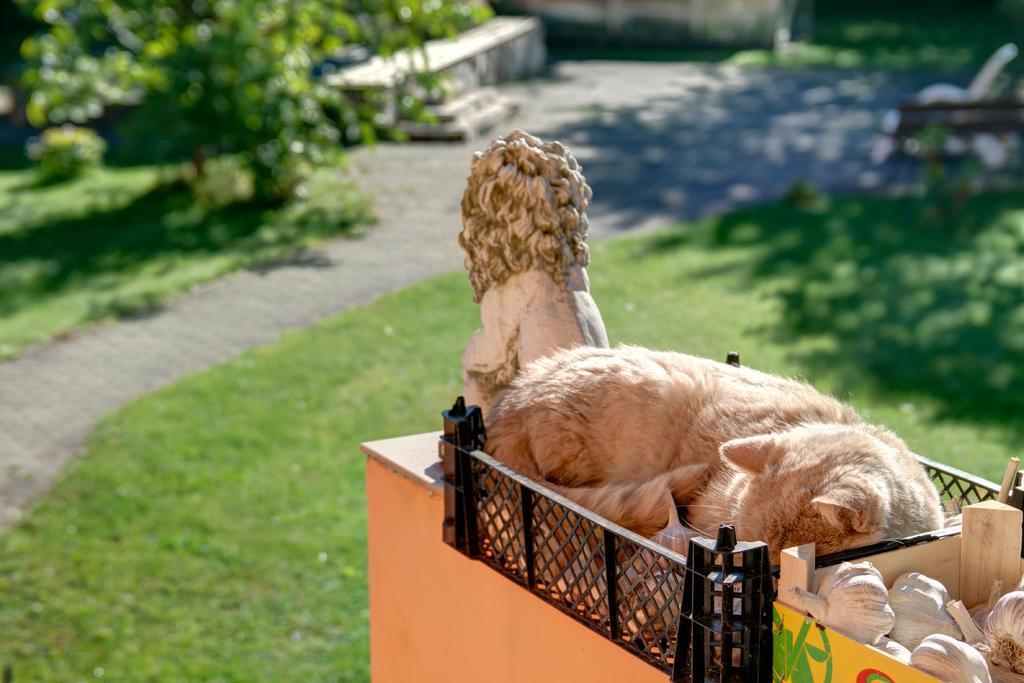Can you describe this image briefly? This picture might be taken outside of the city and it is very sunny. In this image, on the right side corner, we can see a basket inside a basket there are some garlic and a animal lying on the basket, we can also see a statue on the right side. On the left side, there are some trees, at the bottom there is a grass. 